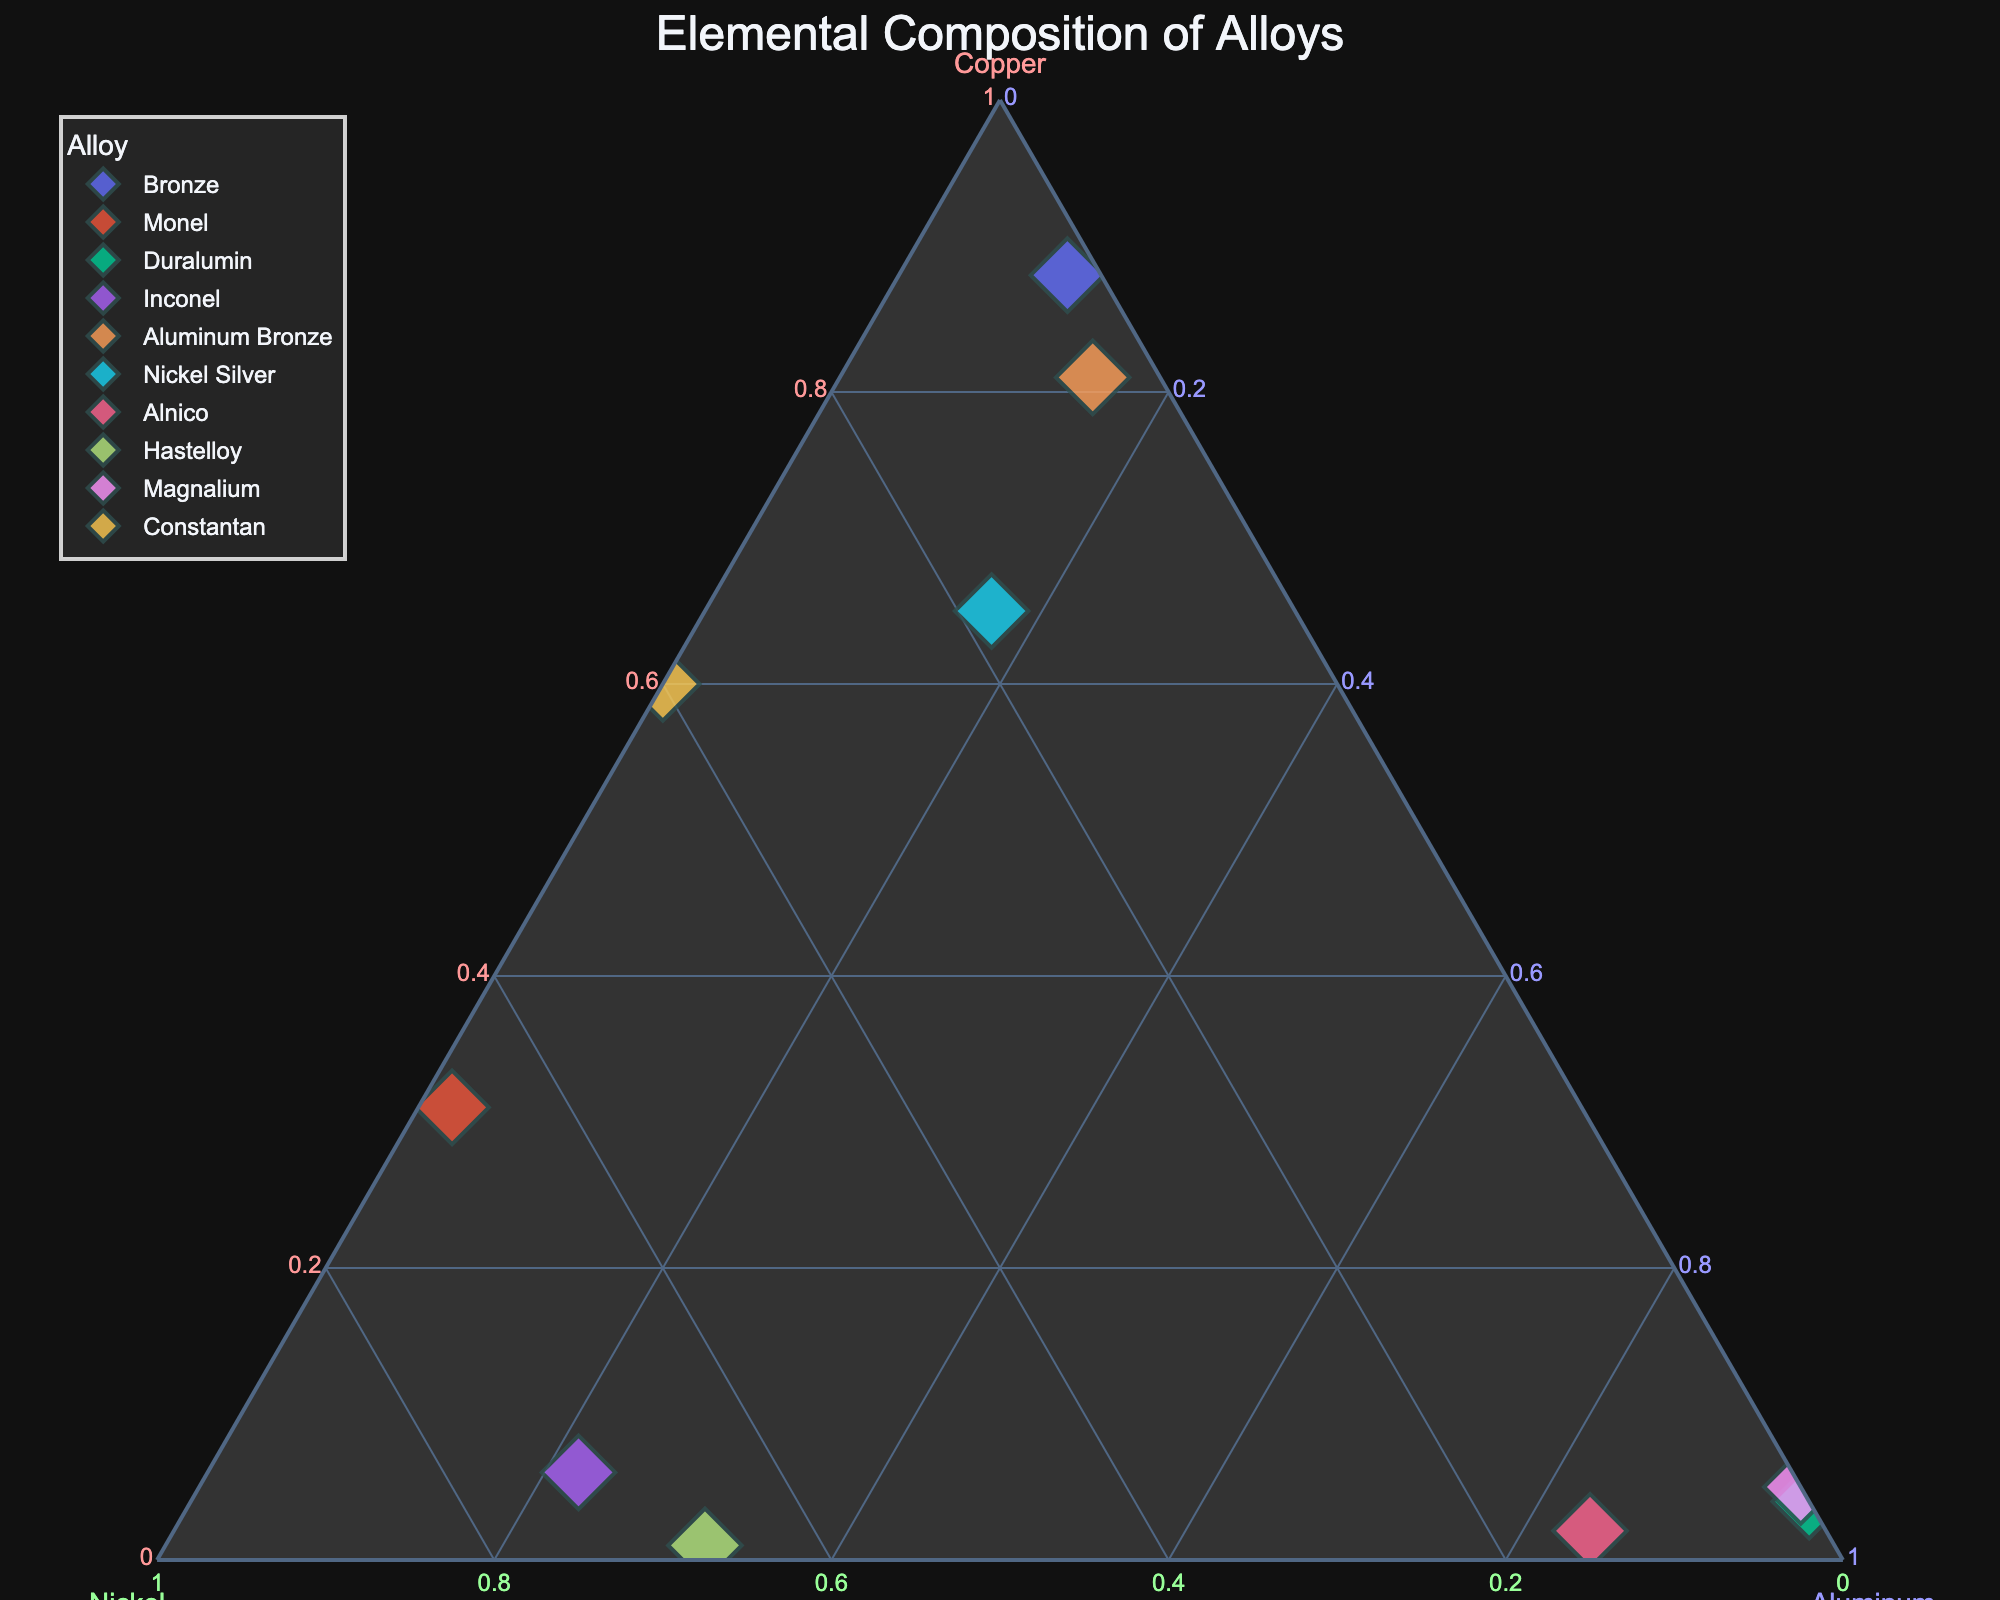What is the ratio of Copper, Nickel, and Aluminum in Bronze? The plot shows the coordinates of Bronze in the ternary diagram. From its positioning, Bronze has 88% Copper, 2% Nickel, and 10% Aluminum.
Answer: 88:2:10 Which alloy has the highest percentage of Aluminum? By observing the vertices of the ternary plot, the point that is closest to the Aluminum vertex represents the highest percentage. Duralumin and Magnalium are both at or near 100% Aluminum.
Answer: Duralumin and Magnalium How many alloys have a Copper percentage higher than 50%? By examining the plot, locate all data points where the coordinates indicate Copper is more than halfway along its axis. These will be the points closer to the Copper vertex. There are four such alloys: Bronze, Aluminum Bronze, Nickel Silver, and Constantan.
Answer: Four Which alloy composition is closest to being evenly distributed among Copper, Nickel, and Aluminum? Find the point in the ternary plot that is closest to the center of the triangle, indicating an even distribution. Nickel Silver is the closest to the center with 65% Copper, 18% Nickel, and 17% Aluminum.
Answer: Nickel Silver Compare the Copper content in Monel and Aluminum Bronze. Which is higher? Locate Monel and Aluminum Bronze on the plot and check their Copper values along the Copper axis. Monel has 31% Copper, while Aluminum Bronze has 81% Copper. Aluminum Bronze has a higher Copper content.
Answer: Aluminum Bronze What is the title of the ternary plot? The title is prominently displayed at the top of the plot.
Answer: Elemental Composition of Alloys Which axis is labeled "Nickel"? The plot typically labels one of the axes as Nickel. This axis is usually indicated with a color distinct from others, in this case, a shade of green.
Answer: The right axis Are there any alloys with no Nickel content? If so, name them. Look at the plot and identify data points along the base of the triangle where the Nickel percentage is 0. Duralumin and Magnalium both have 0% Nickel.
Answer: Duralumin and Magnalium How does the Copper percentage in Inconel compare to that in Bronze? Find the respective points for Inconel and Bronze. Inconel has 6% Copper, while Bronze has 88% Copper. Bronze has significantly more Copper.
Answer: Bronze Which alloy contains a larger percentage of Nickel, Monel or Hastelloy? Locate Monel and Hastelloy and refer to the Nickel axis for their values. Monel has 67% and Hastelloy also has 67%, meaning they contain the same percentage of Nickel.
Answer: They are equal 